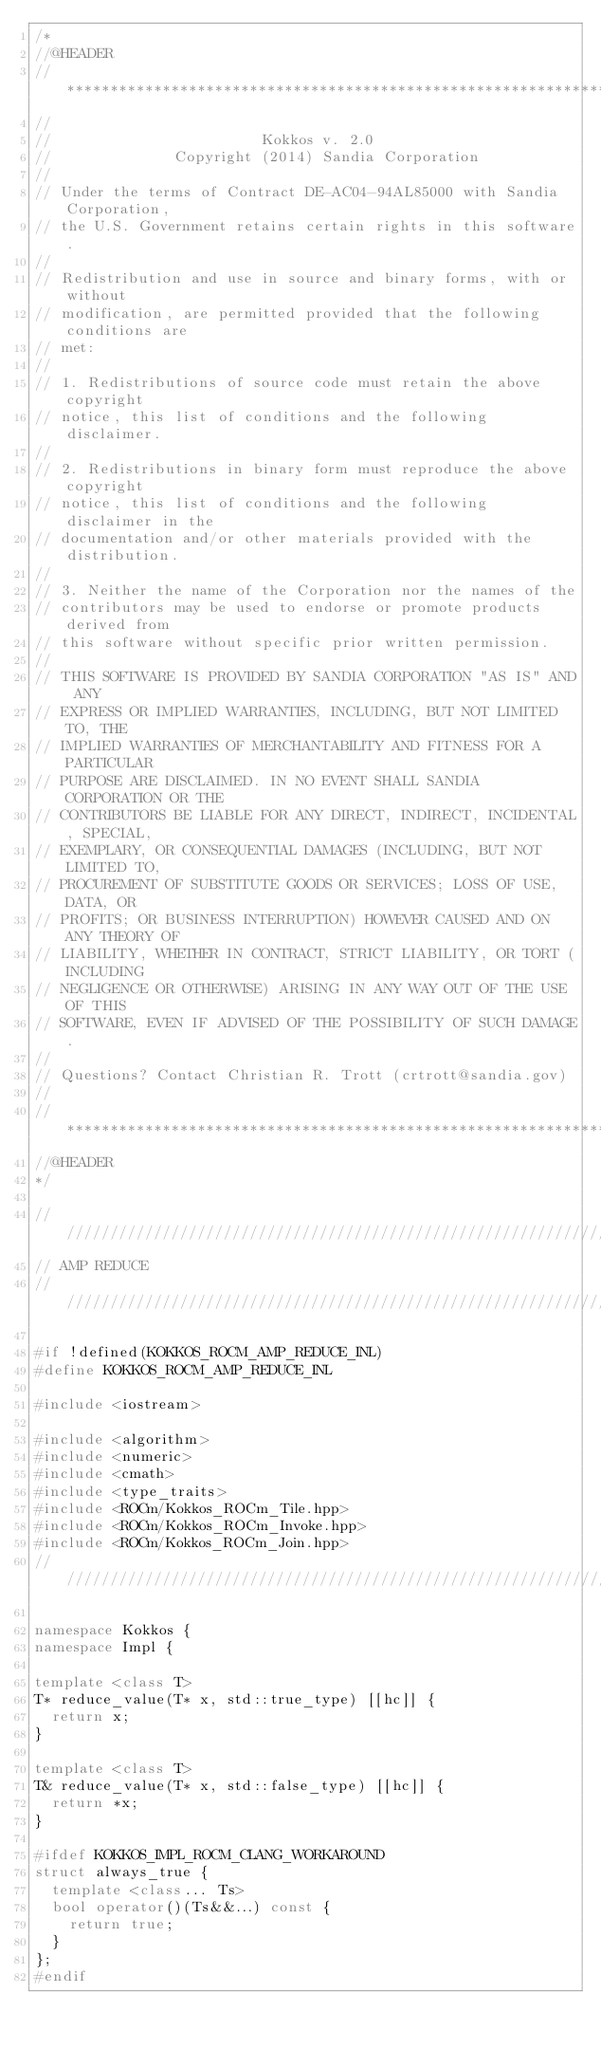Convert code to text. <code><loc_0><loc_0><loc_500><loc_500><_C++_>/*
//@HEADER
// ************************************************************************
//
//                        Kokkos v. 2.0
//              Copyright (2014) Sandia Corporation
//
// Under the terms of Contract DE-AC04-94AL85000 with Sandia Corporation,
// the U.S. Government retains certain rights in this software.
//
// Redistribution and use in source and binary forms, with or without
// modification, are permitted provided that the following conditions are
// met:
//
// 1. Redistributions of source code must retain the above copyright
// notice, this list of conditions and the following disclaimer.
//
// 2. Redistributions in binary form must reproduce the above copyright
// notice, this list of conditions and the following disclaimer in the
// documentation and/or other materials provided with the distribution.
//
// 3. Neither the name of the Corporation nor the names of the
// contributors may be used to endorse or promote products derived from
// this software without specific prior written permission.
//
// THIS SOFTWARE IS PROVIDED BY SANDIA CORPORATION "AS IS" AND ANY
// EXPRESS OR IMPLIED WARRANTIES, INCLUDING, BUT NOT LIMITED TO, THE
// IMPLIED WARRANTIES OF MERCHANTABILITY AND FITNESS FOR A PARTICULAR
// PURPOSE ARE DISCLAIMED. IN NO EVENT SHALL SANDIA CORPORATION OR THE
// CONTRIBUTORS BE LIABLE FOR ANY DIRECT, INDIRECT, INCIDENTAL, SPECIAL,
// EXEMPLARY, OR CONSEQUENTIAL DAMAGES (INCLUDING, BUT NOT LIMITED TO,
// PROCUREMENT OF SUBSTITUTE GOODS OR SERVICES; LOSS OF USE, DATA, OR
// PROFITS; OR BUSINESS INTERRUPTION) HOWEVER CAUSED AND ON ANY THEORY OF
// LIABILITY, WHETHER IN CONTRACT, STRICT LIABILITY, OR TORT (INCLUDING
// NEGLIGENCE OR OTHERWISE) ARISING IN ANY WAY OUT OF THE USE OF THIS
// SOFTWARE, EVEN IF ADVISED OF THE POSSIBILITY OF SUCH DAMAGE.
//
// Questions? Contact Christian R. Trott (crtrott@sandia.gov)
//
// ************************************************************************
//@HEADER
*/

///////////////////////////////////////////////////////////////////////////////
// AMP REDUCE
//////////////////////////////////////////////////////////////////////////////

#if !defined(KOKKOS_ROCM_AMP_REDUCE_INL)
#define KOKKOS_ROCM_AMP_REDUCE_INL

#include <iostream>

#include <algorithm>
#include <numeric>
#include <cmath>
#include <type_traits>
#include <ROCm/Kokkos_ROCm_Tile.hpp>
#include <ROCm/Kokkos_ROCm_Invoke.hpp>
#include <ROCm/Kokkos_ROCm_Join.hpp>
//////////////////////////////////////////////////////////////////////////////////////////////////////////////////////

namespace Kokkos {
namespace Impl {

template <class T>
T* reduce_value(T* x, std::true_type) [[hc]] {
  return x;
}

template <class T>
T& reduce_value(T* x, std::false_type) [[hc]] {
  return *x;
}

#ifdef KOKKOS_IMPL_ROCM_CLANG_WORKAROUND
struct always_true {
  template <class... Ts>
  bool operator()(Ts&&...) const {
    return true;
  }
};
#endif
</code> 